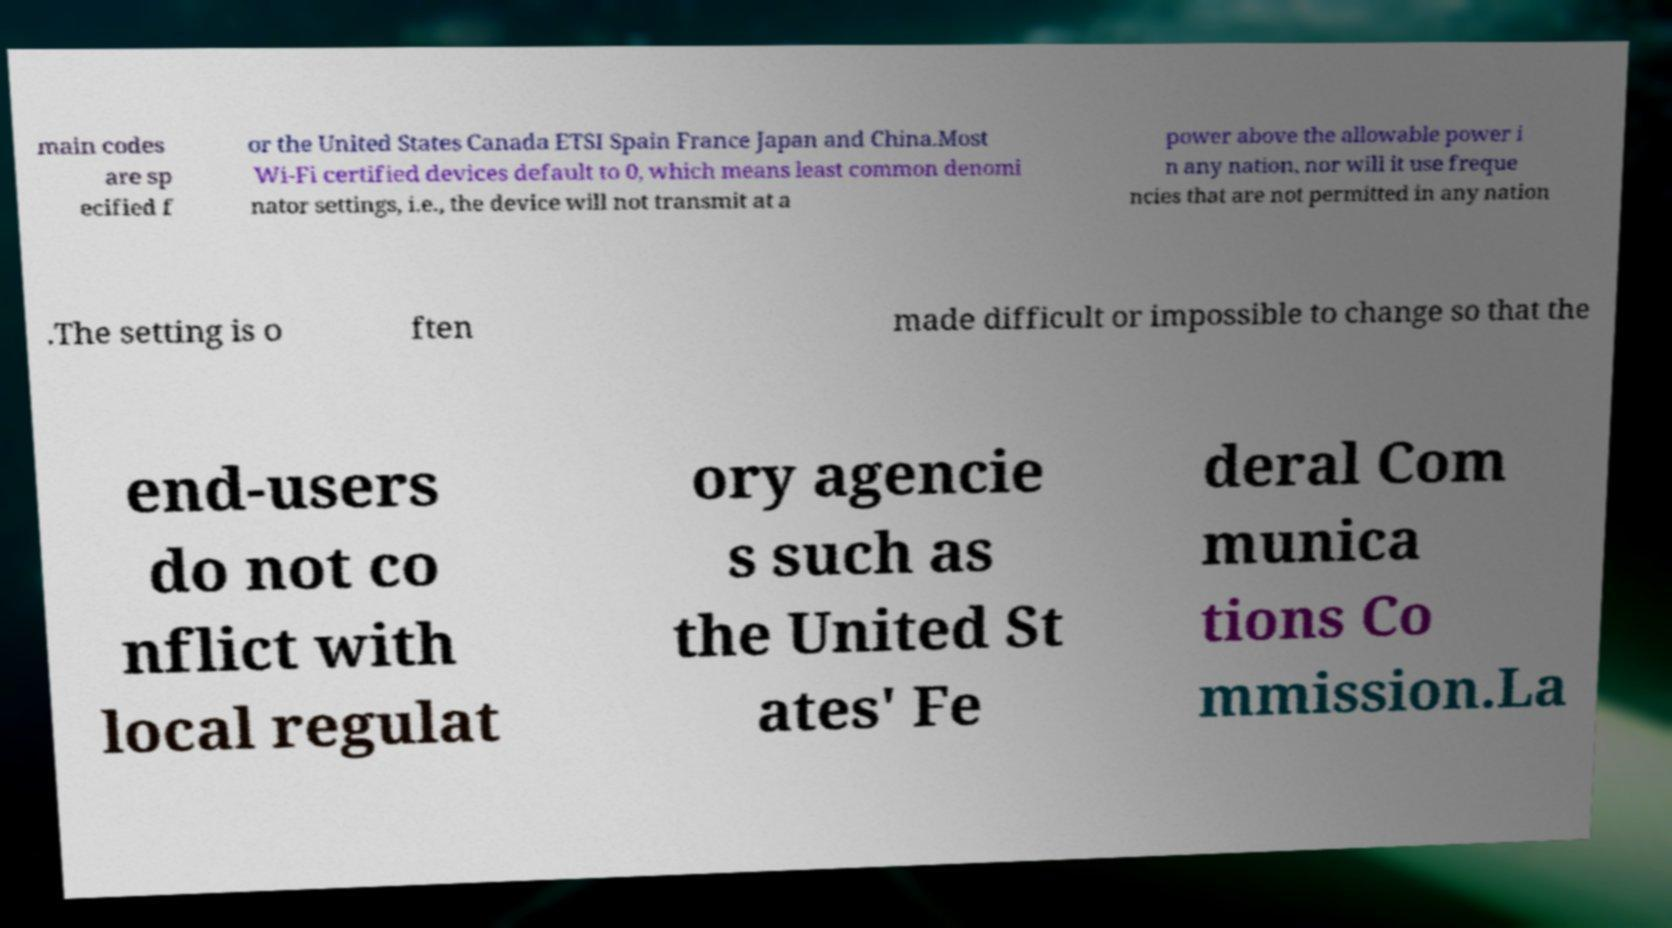Can you read and provide the text displayed in the image?This photo seems to have some interesting text. Can you extract and type it out for me? main codes are sp ecified f or the United States Canada ETSI Spain France Japan and China.Most Wi-Fi certified devices default to 0, which means least common denomi nator settings, i.e., the device will not transmit at a power above the allowable power i n any nation, nor will it use freque ncies that are not permitted in any nation .The setting is o ften made difficult or impossible to change so that the end-users do not co nflict with local regulat ory agencie s such as the United St ates' Fe deral Com munica tions Co mmission.La 